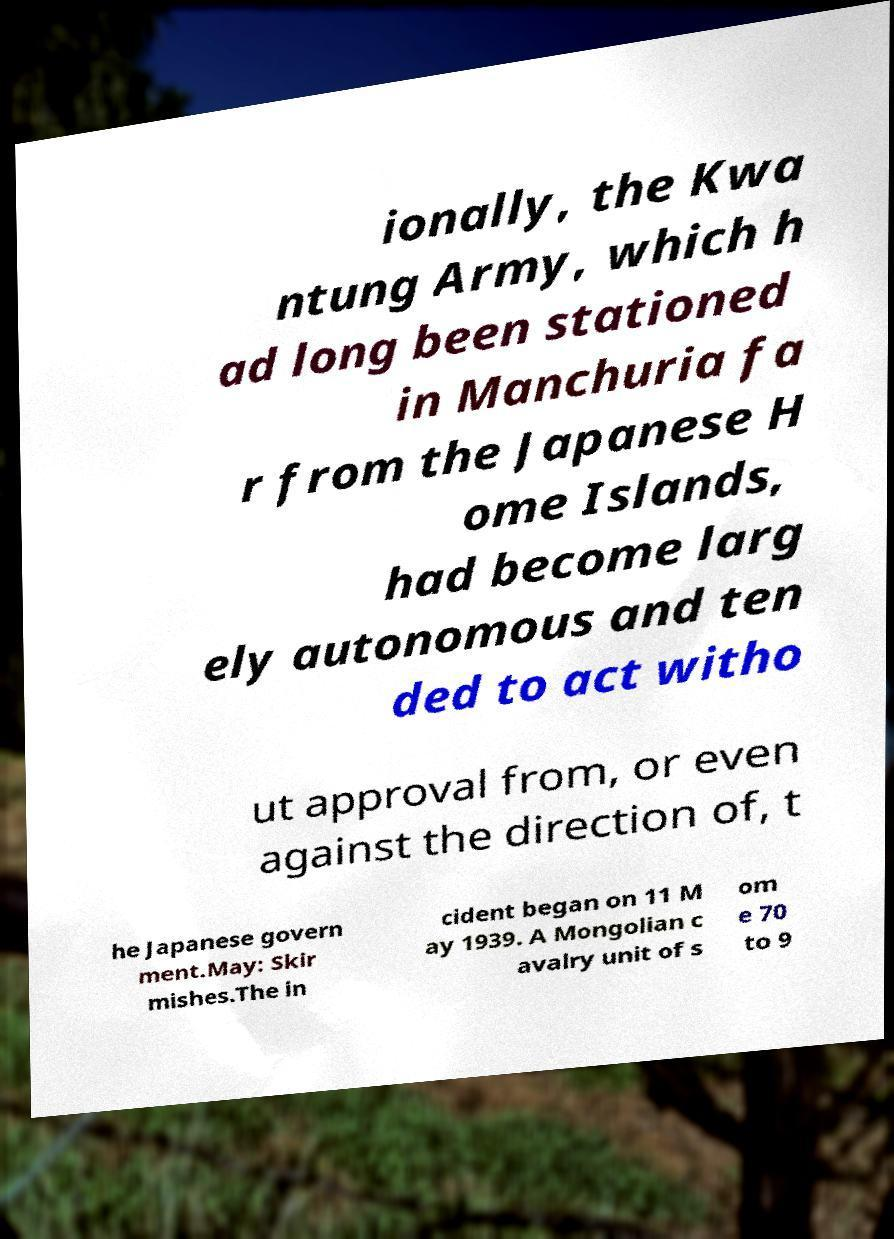Could you assist in decoding the text presented in this image and type it out clearly? ionally, the Kwa ntung Army, which h ad long been stationed in Manchuria fa r from the Japanese H ome Islands, had become larg ely autonomous and ten ded to act witho ut approval from, or even against the direction of, t he Japanese govern ment.May: Skir mishes.The in cident began on 11 M ay 1939. A Mongolian c avalry unit of s om e 70 to 9 